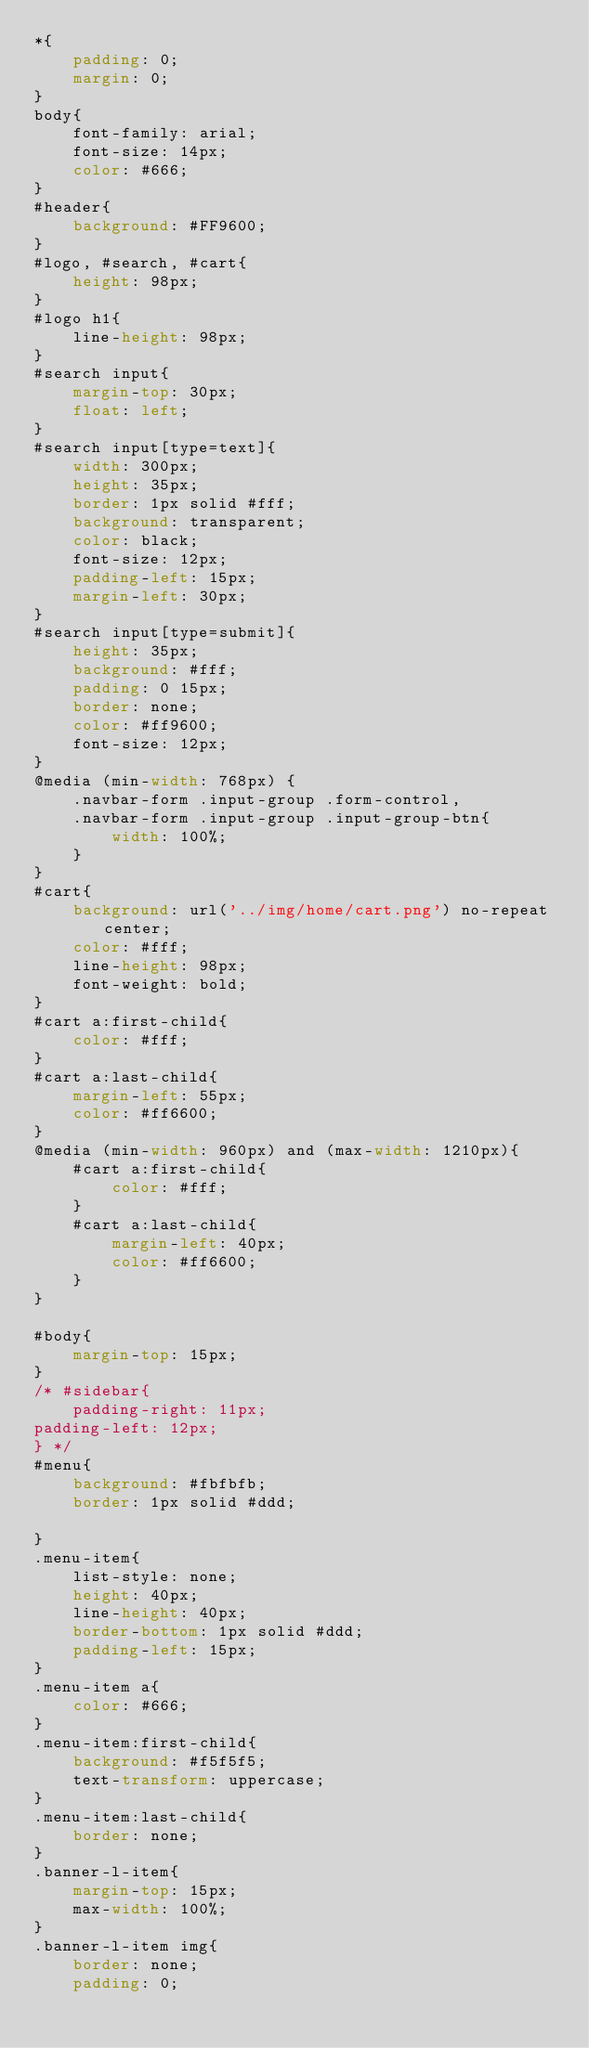Convert code to text. <code><loc_0><loc_0><loc_500><loc_500><_CSS_>*{
	padding: 0;
	margin: 0;
}
body{
	font-family: arial;
	font-size: 14px;
	color: #666;
}
#header{
	background: #FF9600;
}
#logo, #search, #cart{
	height: 98px;
}
#logo h1{
	line-height: 98px;
}
#search input{
	margin-top: 30px;
	float: left;
}
#search input[type=text]{
	width: 300px;
	height: 35px;
	border: 1px solid #fff;
	background: transparent;
	color: black;
	font-size: 12px;
	padding-left: 15px;
	margin-left: 30px;
}
#search input[type=submit]{
	height: 35px;
	background: #fff;
	padding: 0 15px;
	border: none;
	color: #ff9600;
	font-size: 12px;
}
@media (min-width: 768px) {
	.navbar-form .input-group .form-control,
	.navbar-form .input-group .input-group-btn{
		width: 100%;
	}
}
#cart{
	background: url('../img/home/cart.png') no-repeat center;
	color: #fff;
	line-height: 98px;
	font-weight: bold;
}
#cart a:first-child{
	color: #fff;
}
#cart a:last-child{
	margin-left: 55px;
	color: #ff6600;
}
@media (min-width: 960px) and (max-width: 1210px){
	#cart a:first-child{
		color: #fff;
	}
	#cart a:last-child{
		margin-left: 40px;
		color: #ff6600;
	}
}

#body{
	margin-top: 15px;
}
/* #sidebar{
	padding-right: 11px;
padding-left: 12px;
} */
#menu{
	background: #fbfbfb;
	border: 1px solid #ddd;

}
.menu-item{
	list-style: none;
	height: 40px;
	line-height: 40px;
	border-bottom: 1px solid #ddd;
	padding-left: 15px;
}
.menu-item a{
	color: #666;
}
.menu-item:first-child{
	background: #f5f5f5;
	text-transform: uppercase;
}
.menu-item:last-child{
	border: none;
}
.banner-l-item{
	margin-top: 15px;
	max-width: 100%;
}
.banner-l-item img{
	border: none;
	padding: 0;</code> 